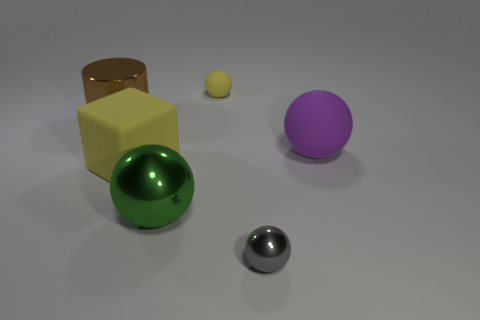Is there any other thing that is the same shape as the big brown object?
Give a very brief answer. No. Are there any yellow matte balls right of the gray sphere?
Your response must be concise. No. What color is the cylinder that is made of the same material as the gray thing?
Give a very brief answer. Brown. There is a rubber object that is behind the big purple matte object; is it the same color as the big rubber thing to the left of the green metallic thing?
Offer a terse response. Yes. What number of spheres are either large cyan objects or big metallic things?
Give a very brief answer. 1. Are there the same number of yellow things behind the brown shiny object and big green metal spheres?
Give a very brief answer. Yes. What is the material of the big sphere in front of the large matte thing that is on the left side of the thing that is on the right side of the gray shiny thing?
Your answer should be compact. Metal. What number of things are rubber balls to the right of the tiny yellow matte object or purple cylinders?
Ensure brevity in your answer.  1. How many objects are either small matte things or large objects that are to the right of the big green ball?
Offer a terse response. 2. There is a big thing that is to the right of the matte thing behind the big purple object; what number of matte objects are in front of it?
Make the answer very short. 1. 